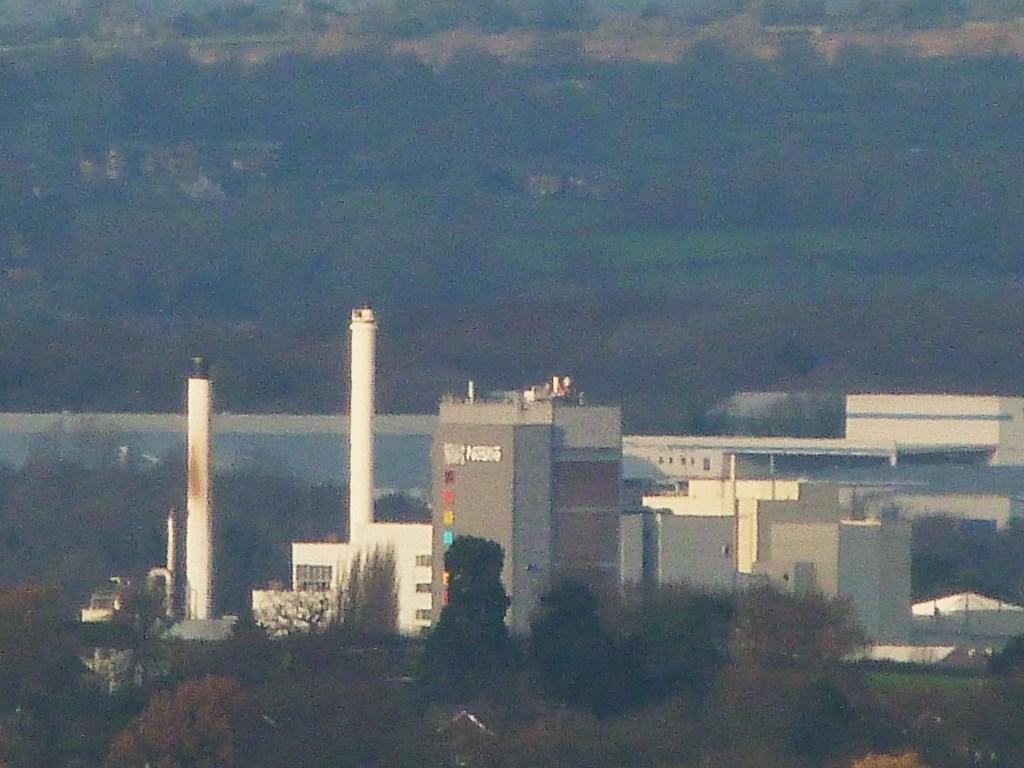What type of structures can be seen in the image? There are buildings in the image. What type of vegetation is present in the image? There are trees in the image. Can you tell me how the beetle is expressing anger in the image? There is no beetle present in the image, and therefore no such expression of anger can be observed. What type of frog can be seen sitting on the building in the image? There is no frog present in the image, and therefore no such activity can be observed. 